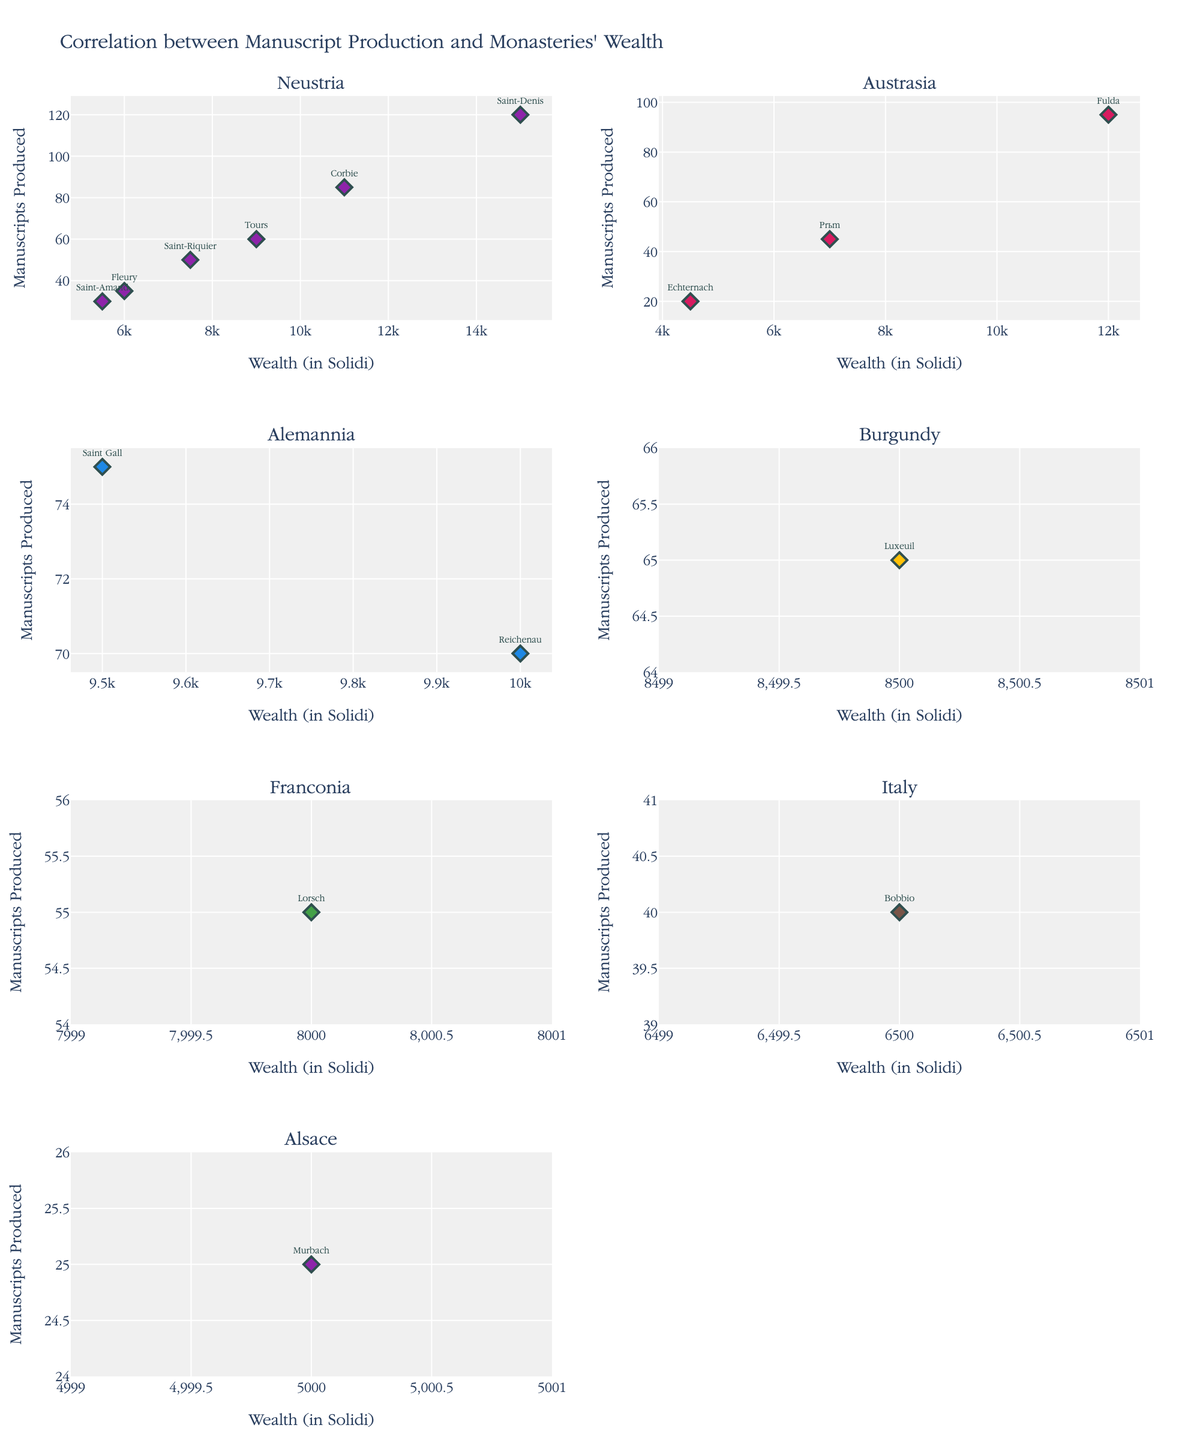What is the title of the figure? The title is usually displayed at the top of the figure. In this case, it shows the purpose of the figure by mentioning the correlation being studied.
Answer: Correlation between Manuscript Production and Monasteries' Wealth What is the range of "Wealth (in Solidi)" for the Neustria region? By examining the x-axes of the subplots, we can determine the minimum and maximum "Wealth (in Solidi)" values for the Neustria region's subplot.
Answer: 5500 to 15000 How many monasteries are plotted in the subplots for the Austrasia region? Locate the subplot for the Austrasia region and count the number of distinct data points (markers) represented.
Answer: 3 Which monastery in the Alemannia region produced the most manuscripts? In the subplot for the Alemannia region, identify the marker with the highest position on the y-axis and read off the corresponding monastery name.
Answer: Saint Gall What's the difference in manuscripts produced between the wealthiest and the poorest monasteries in the Neustria region? First, identify the wealthiest (Saint-Denis) and the poorest (Saint-Amand) monasteries in the Neustria subplot. Compare the number of manuscripts produced by these monasteries.
Answer: 90 Which region has the monastery with the highest wealth? Identify the subplot with the highest value on the x-axis and then note the region title.
Answer: Neustria Is there a general trend between wealth and manuscripts produced in the Austrasia region? Observe the positioning of the markers in the Austrasia subplot to see if there is an increasing or decreasing pattern from left to right.
Answer: Increasing Are there any regions where more wealth does not correspond to more manuscripts produced? Examine each subplot and compare the general trends. If the markers do not show a positive correlation (increasing trend), that region fits the description.
Answer: Fleury in Neustria What's the median number of manuscripts produced in the Alemannia region? Arrange the number of manuscripts produced in non-decreasing order for Alemannia's monasteries, and find the middle value.
Answer: 72.5 Which regions have monasteries with less than 50 manuscripts produced? Identify and list all regions with markers below the 50 mark on the y-axis in their subplots.
Answer: Austrasia, Neustria, Alsace 